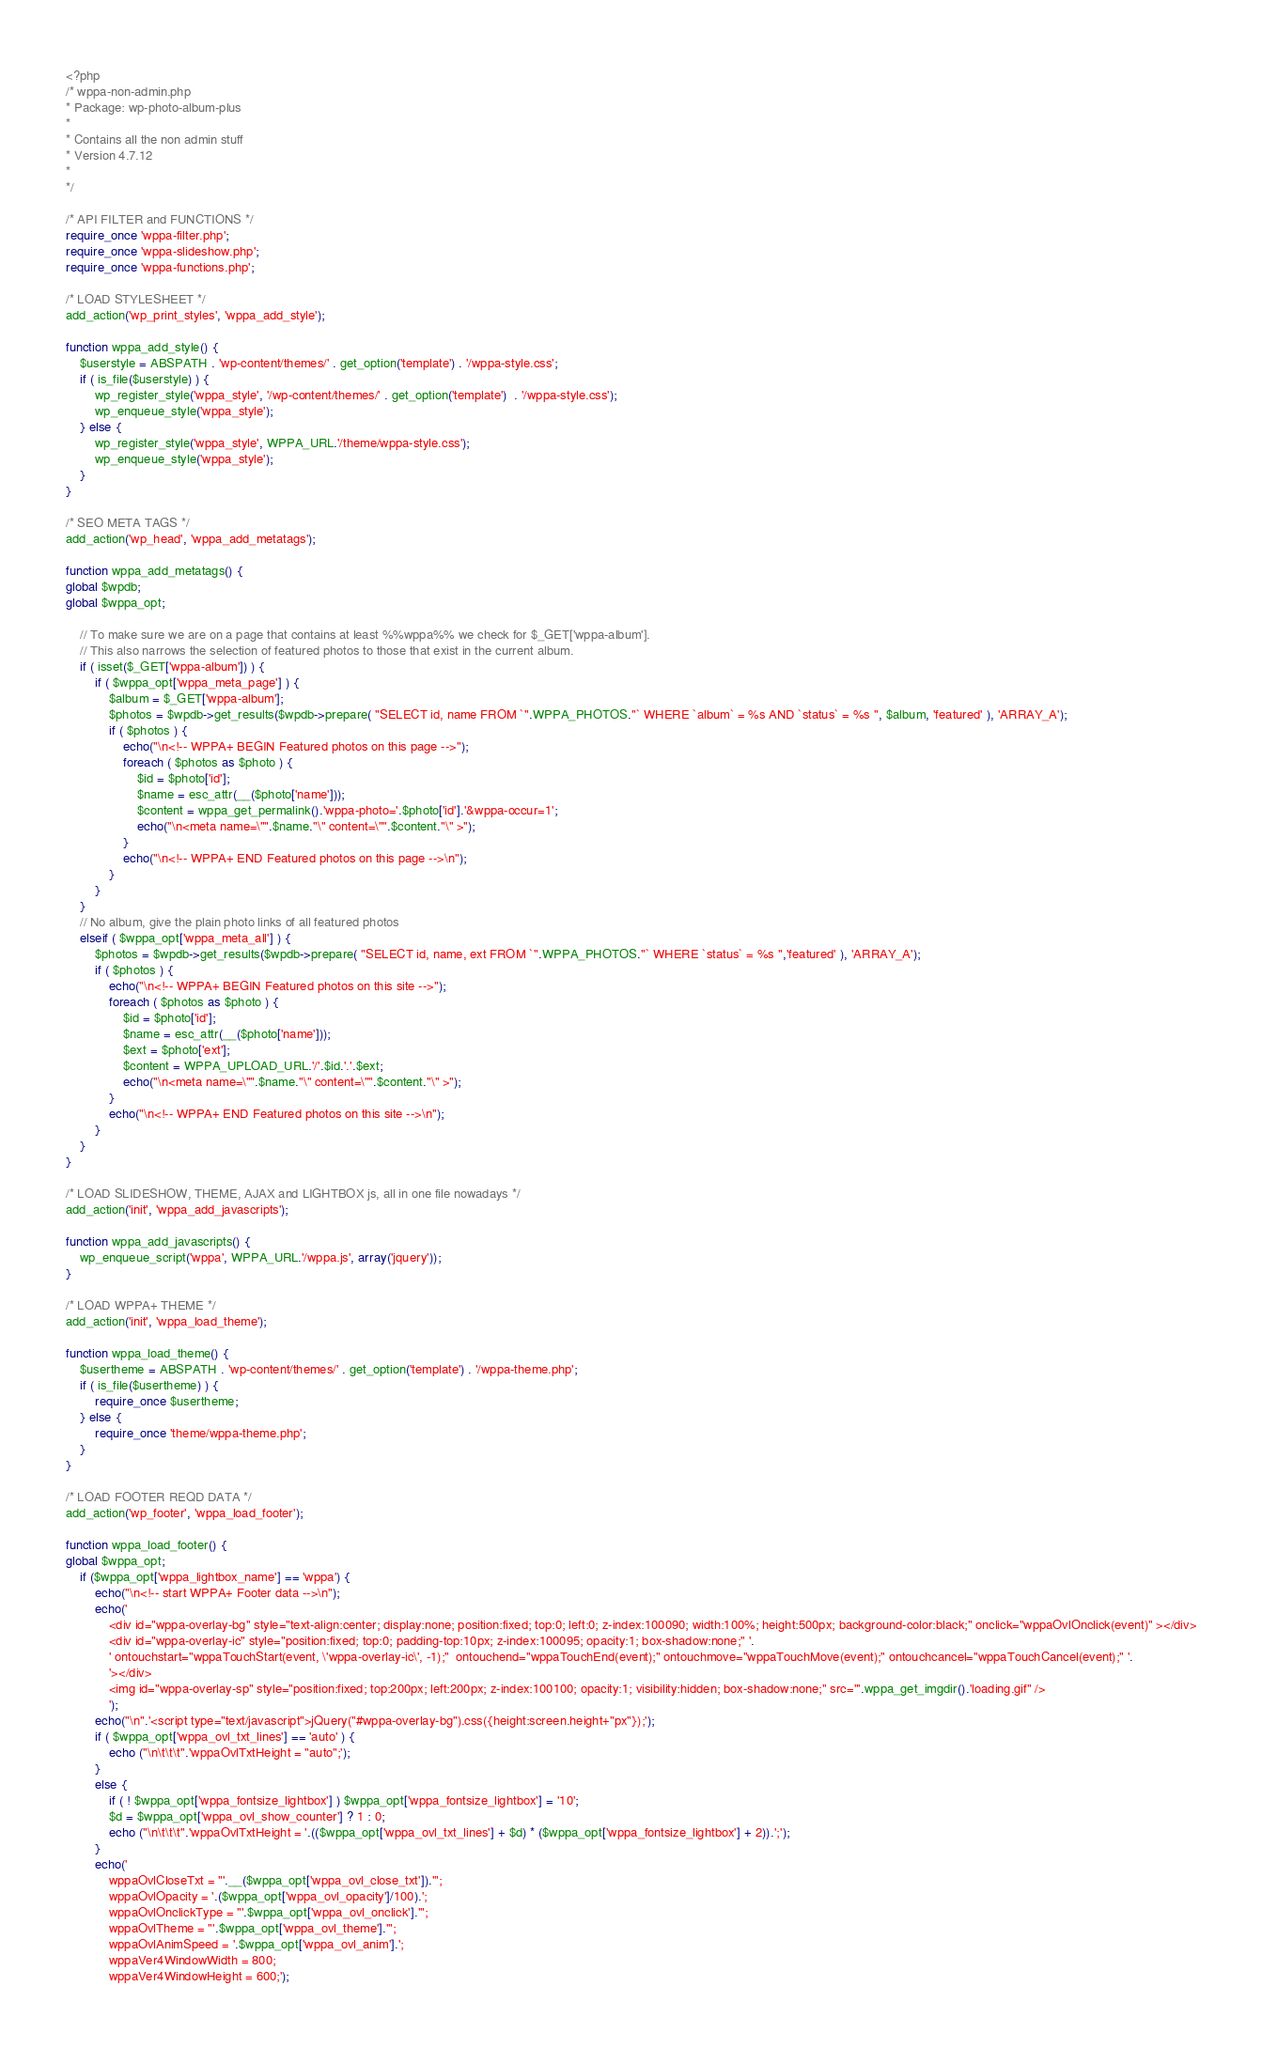Convert code to text. <code><loc_0><loc_0><loc_500><loc_500><_PHP_><?php 
/* wppa-non-admin.php
* Package: wp-photo-album-plus
*
* Contains all the non admin stuff
* Version 4.7.12
*
*/

/* API FILTER and FUNCTIONS */
require_once 'wppa-filter.php';
require_once 'wppa-slideshow.php';
require_once 'wppa-functions.php';
	
/* LOAD STYLESHEET */
add_action('wp_print_styles', 'wppa_add_style');

function wppa_add_style() {
	$userstyle = ABSPATH . 'wp-content/themes/' . get_option('template') . '/wppa-style.css';
	if ( is_file($userstyle) ) {
		wp_register_style('wppa_style', '/wp-content/themes/' . get_option('template')  . '/wppa-style.css');
		wp_enqueue_style('wppa_style');
	} else {
		wp_register_style('wppa_style', WPPA_URL.'/theme/wppa-style.css');
		wp_enqueue_style('wppa_style');
	}
}

/* SEO META TAGS */
add_action('wp_head', 'wppa_add_metatags');

function wppa_add_metatags() {
global $wpdb;
global $wppa_opt;

	// To make sure we are on a page that contains at least %%wppa%% we check for $_GET['wppa-album']. 
	// This also narrows the selection of featured photos to those that exist in the current album.
	if ( isset($_GET['wppa-album']) ) {
		if ( $wppa_opt['wppa_meta_page'] ) {
			$album = $_GET['wppa-album'];
			$photos = $wpdb->get_results($wpdb->prepare( "SELECT id, name FROM `".WPPA_PHOTOS."` WHERE `album` = %s AND `status` = %s ", $album, 'featured' ), 'ARRAY_A');
			if ( $photos ) {
				echo("\n<!-- WPPA+ BEGIN Featured photos on this page -->");
				foreach ( $photos as $photo ) {
					$id = $photo['id'];
					$name = esc_attr(__($photo['name']));
					$content = wppa_get_permalink().'wppa-photo='.$photo['id'].'&wppa-occur=1';
					echo("\n<meta name=\"".$name."\" content=\"".$content."\" >");
				}
				echo("\n<!-- WPPA+ END Featured photos on this page -->\n");
			}
		}
	}
	// No album, give the plain photo links of all featured photos
	elseif ( $wppa_opt['wppa_meta_all'] ) {
		$photos = $wpdb->get_results($wpdb->prepare( "SELECT id, name, ext FROM `".WPPA_PHOTOS."` WHERE `status` = %s ",'featured' ), 'ARRAY_A');
		if ( $photos ) {
			echo("\n<!-- WPPA+ BEGIN Featured photos on this site -->");
			foreach ( $photos as $photo ) {
				$id = $photo['id'];
				$name = esc_attr(__($photo['name']));
				$ext = $photo['ext'];
				$content = WPPA_UPLOAD_URL.'/'.$id.'.'.$ext;
				echo("\n<meta name=\"".$name."\" content=\"".$content."\" >");
			}
			echo("\n<!-- WPPA+ END Featured photos on this site -->\n");
		}
	}
}

/* LOAD SLIDESHOW, THEME, AJAX and LIGHTBOX js, all in one file nowadays */
add_action('init', 'wppa_add_javascripts');
	
function wppa_add_javascripts() {
	wp_enqueue_script('wppa', WPPA_URL.'/wppa.js', array('jquery'));
}
	
/* LOAD WPPA+ THEME */
add_action('init', 'wppa_load_theme');
	
function wppa_load_theme() {
	$usertheme = ABSPATH . 'wp-content/themes/' . get_option('template') . '/wppa-theme.php';
	if ( is_file($usertheme) ) {
		require_once $usertheme;
	} else {
		require_once 'theme/wppa-theme.php';
	}
}
	
/* LOAD FOOTER REQD DATA */
add_action('wp_footer', 'wppa_load_footer');

function wppa_load_footer() {
global $wppa_opt;
	if ($wppa_opt['wppa_lightbox_name'] == 'wppa') {
		echo("\n<!-- start WPPA+ Footer data -->\n");
		echo('
			<div id="wppa-overlay-bg" style="text-align:center; display:none; position:fixed; top:0; left:0; z-index:100090; width:100%; height:500px; background-color:black;" onclick="wppaOvlOnclick(event)" ></div>
			<div id="wppa-overlay-ic" style="position:fixed; top:0; padding-top:10px; z-index:100095; opacity:1; box-shadow:none;" '.
			' ontouchstart="wppaTouchStart(event, \'wppa-overlay-ic\', -1);"  ontouchend="wppaTouchEnd(event);" ontouchmove="wppaTouchMove(event);" ontouchcancel="wppaTouchCancel(event);" '.
			'></div>
			<img id="wppa-overlay-sp" style="position:fixed; top:200px; left:200px; z-index:100100; opacity:1; visibility:hidden; box-shadow:none;" src="'.wppa_get_imgdir().'loading.gif" />
			');
		echo("\n".'<script type="text/javascript">jQuery("#wppa-overlay-bg").css({height:screen.height+"px"});');
		if ( $wppa_opt['wppa_ovl_txt_lines'] == 'auto' ) {
			echo ("\n\t\t\t".'wppaOvlTxtHeight = "auto";');
		}
		else {
			if ( ! $wppa_opt['wppa_fontsize_lightbox'] ) $wppa_opt['wppa_fontsize_lightbox'] = '10';
			$d = $wppa_opt['wppa_ovl_show_counter'] ? 1 : 0;
			echo ("\n\t\t\t".'wppaOvlTxtHeight = '.(($wppa_opt['wppa_ovl_txt_lines'] + $d) * ($wppa_opt['wppa_fontsize_lightbox'] + 2)).';');
		}
		echo('
			wppaOvlCloseTxt = "'.__($wppa_opt['wppa_ovl_close_txt']).'";
			wppaOvlOpacity = '.($wppa_opt['wppa_ovl_opacity']/100).';
			wppaOvlOnclickType = "'.$wppa_opt['wppa_ovl_onclick'].'";
			wppaOvlTheme = "'.$wppa_opt['wppa_ovl_theme'].'";
			wppaOvlAnimSpeed = '.$wppa_opt['wppa_ovl_anim'].';
			wppaVer4WindowWidth = 800;
			wppaVer4WindowHeight = 600;');</code> 